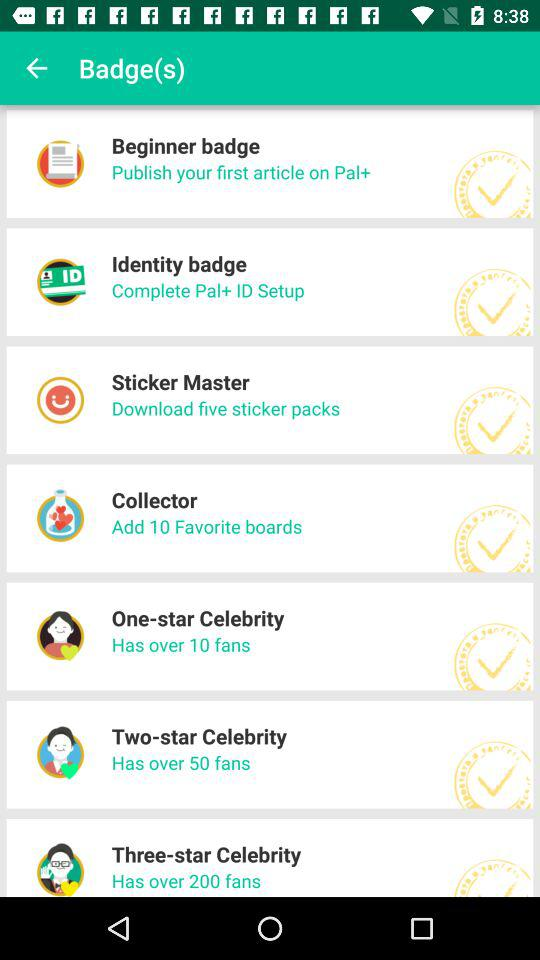What badge has over 200 fans? The badge that has over 200 fans is the three-star celebrity. 